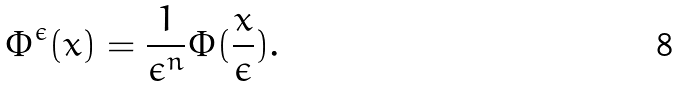Convert formula to latex. <formula><loc_0><loc_0><loc_500><loc_500>\Phi ^ { \epsilon } ( x ) = \frac { 1 } { \epsilon ^ { n } } \Phi ( \frac { x } { \epsilon } ) .</formula> 